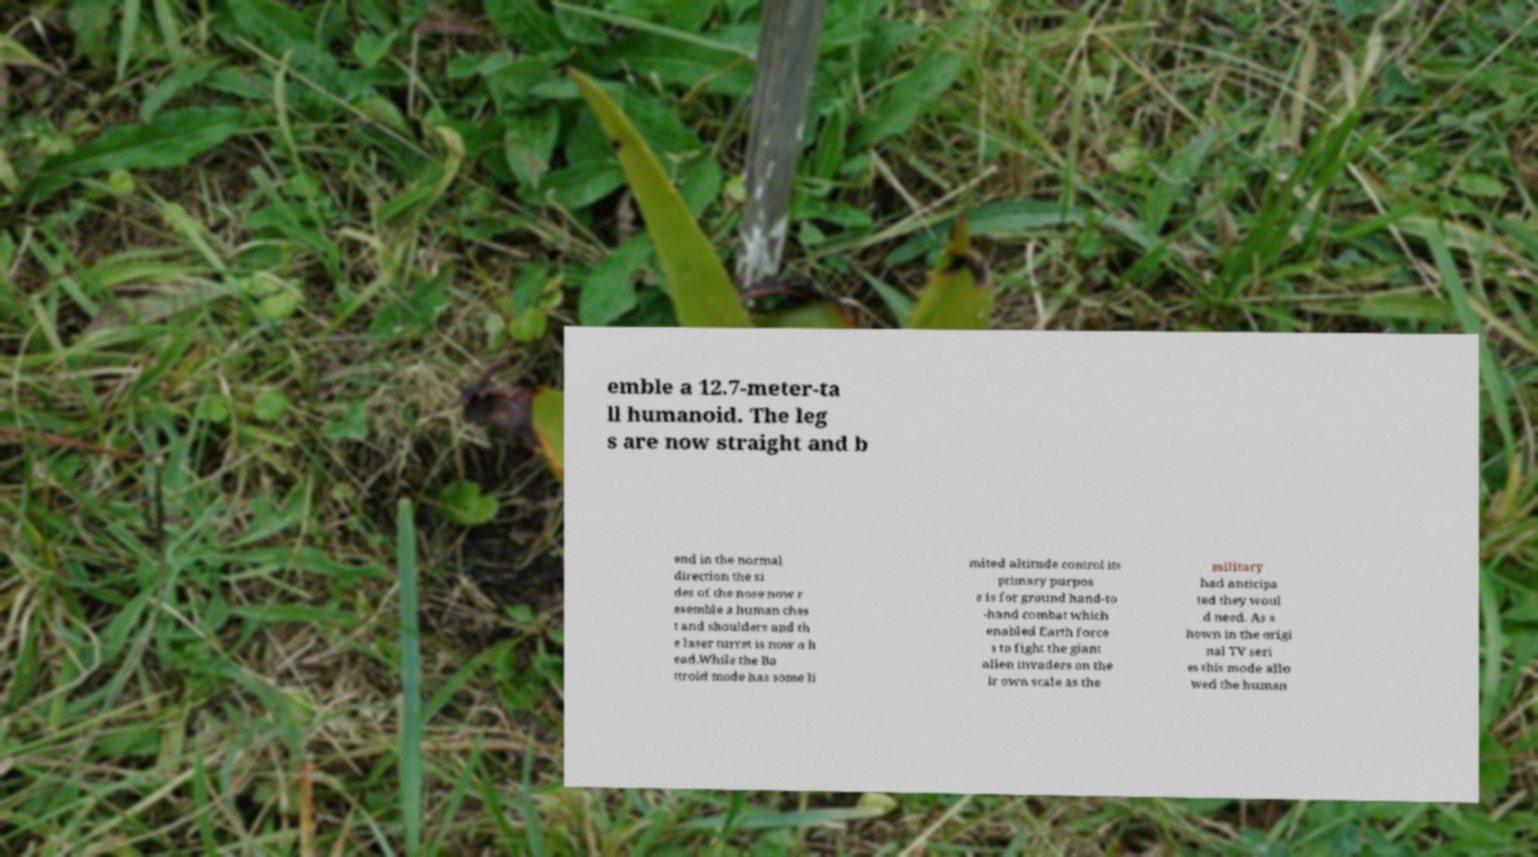What messages or text are displayed in this image? I need them in a readable, typed format. emble a 12.7-meter-ta ll humanoid. The leg s are now straight and b end in the normal direction the si des of the nose now r esemble a human ches t and shoulders and th e laser turret is now a h ead.While the Ba ttroid mode has some li mited altitude control its primary purpos e is for ground hand-to -hand combat which enabled Earth force s to fight the giant alien invaders on the ir own scale as the military had anticipa ted they woul d need. As s hown in the origi nal TV seri es this mode allo wed the human 